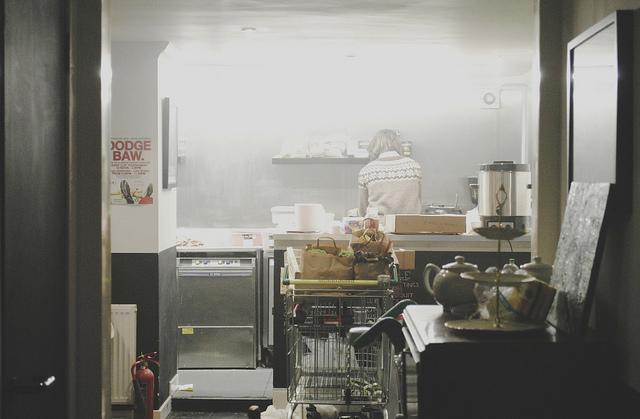What is the woman doing?
Select the accurate response from the four choices given to answer the question.
Options: Eating, talking, sleeping, working. Working. 